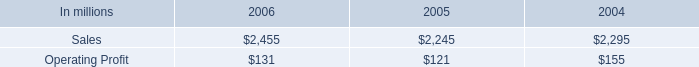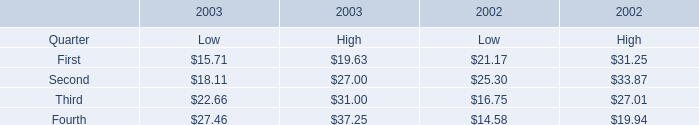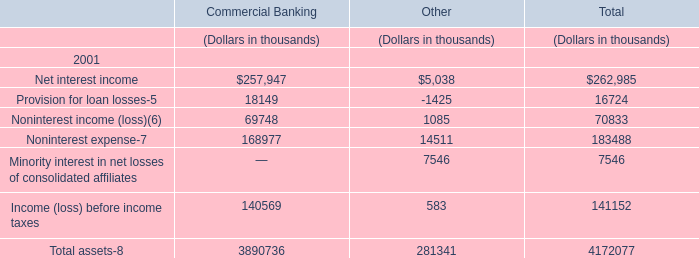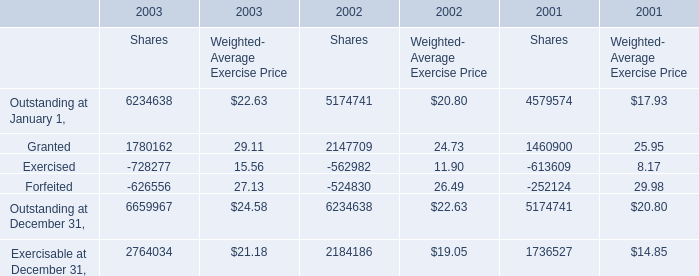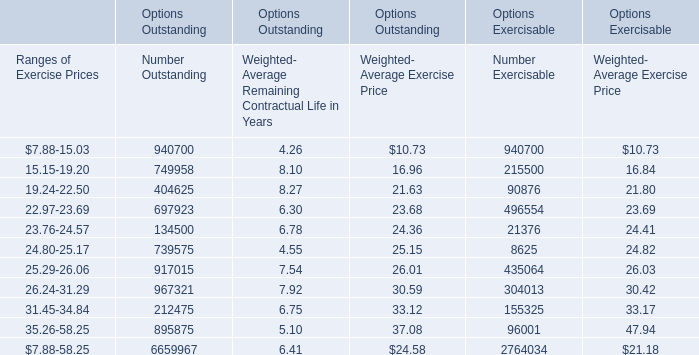What will Outstanding at January 1 for Weighted- Average Exercise Price in 2004 if it continues to grow at its current rate? 
Computations: (22.63 * (1 + ((22.63 - 20.8) / 20.8)))
Answer: 24.621. 